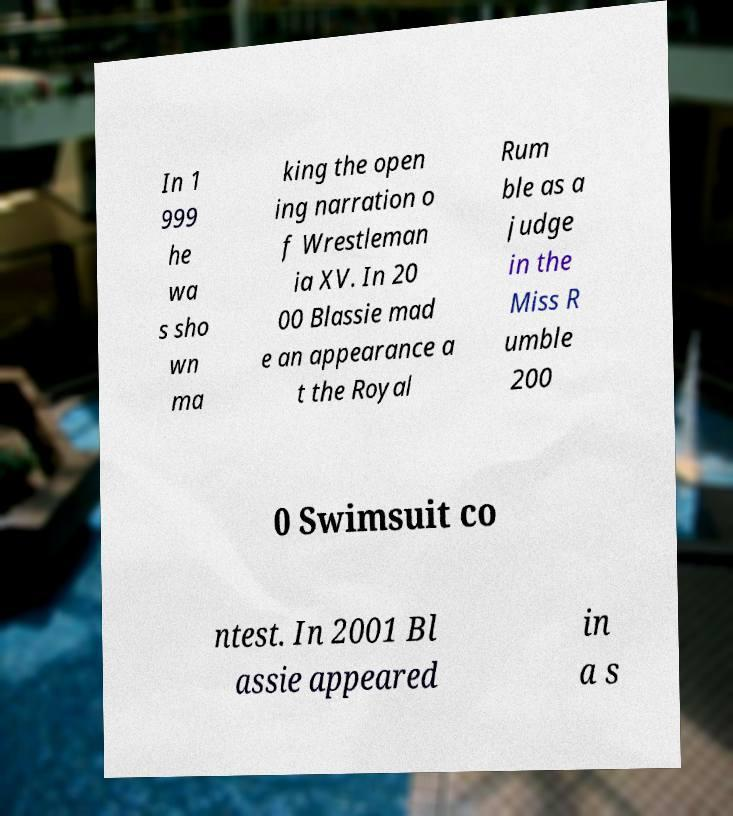Can you read and provide the text displayed in the image?This photo seems to have some interesting text. Can you extract and type it out for me? In 1 999 he wa s sho wn ma king the open ing narration o f Wrestleman ia XV. In 20 00 Blassie mad e an appearance a t the Royal Rum ble as a judge in the Miss R umble 200 0 Swimsuit co ntest. In 2001 Bl assie appeared in a s 